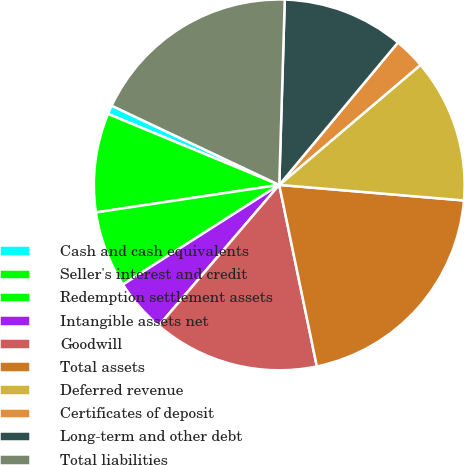Convert chart to OTSL. <chart><loc_0><loc_0><loc_500><loc_500><pie_chart><fcel>Cash and cash equivalents<fcel>Seller's interest and credit<fcel>Redemption settlement assets<fcel>Intangible assets net<fcel>Goodwill<fcel>Total assets<fcel>Deferred revenue<fcel>Certificates of deposit<fcel>Long-term and other debt<fcel>Total liabilities<nl><fcel>0.77%<fcel>8.63%<fcel>6.66%<fcel>4.7%<fcel>14.52%<fcel>20.41%<fcel>12.55%<fcel>2.73%<fcel>10.59%<fcel>18.45%<nl></chart> 